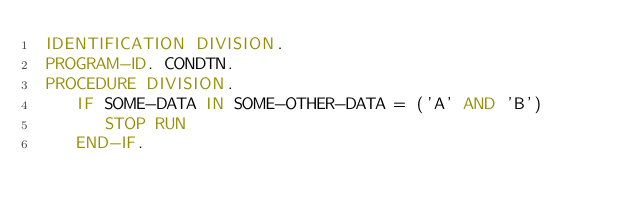Convert code to text. <code><loc_0><loc_0><loc_500><loc_500><_COBOL_> IDENTIFICATION DIVISION.
 PROGRAM-ID. CONDTN.
 PROCEDURE DIVISION.
    IF SOME-DATA IN SOME-OTHER-DATA = ('A' AND 'B')
       STOP RUN
    END-IF.
</code> 